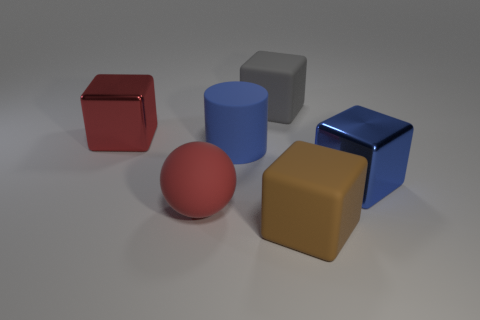Subtract all brown rubber blocks. How many blocks are left? 3 Add 4 red cylinders. How many objects exist? 10 Subtract all red blocks. How many blocks are left? 3 Subtract all spheres. How many objects are left? 5 Subtract 1 red balls. How many objects are left? 5 Subtract all red blocks. Subtract all brown cylinders. How many blocks are left? 3 Subtract all large brown matte cubes. Subtract all blue matte things. How many objects are left? 4 Add 6 matte things. How many matte things are left? 10 Add 3 red matte spheres. How many red matte spheres exist? 4 